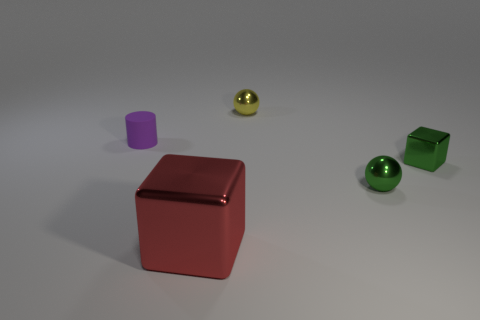What is the lighting like in this image? The lighting in the image is soft and diffuse, coming from above. It creates soft shadows under the objects, suggesting an indoor setting with ambient lighting. 